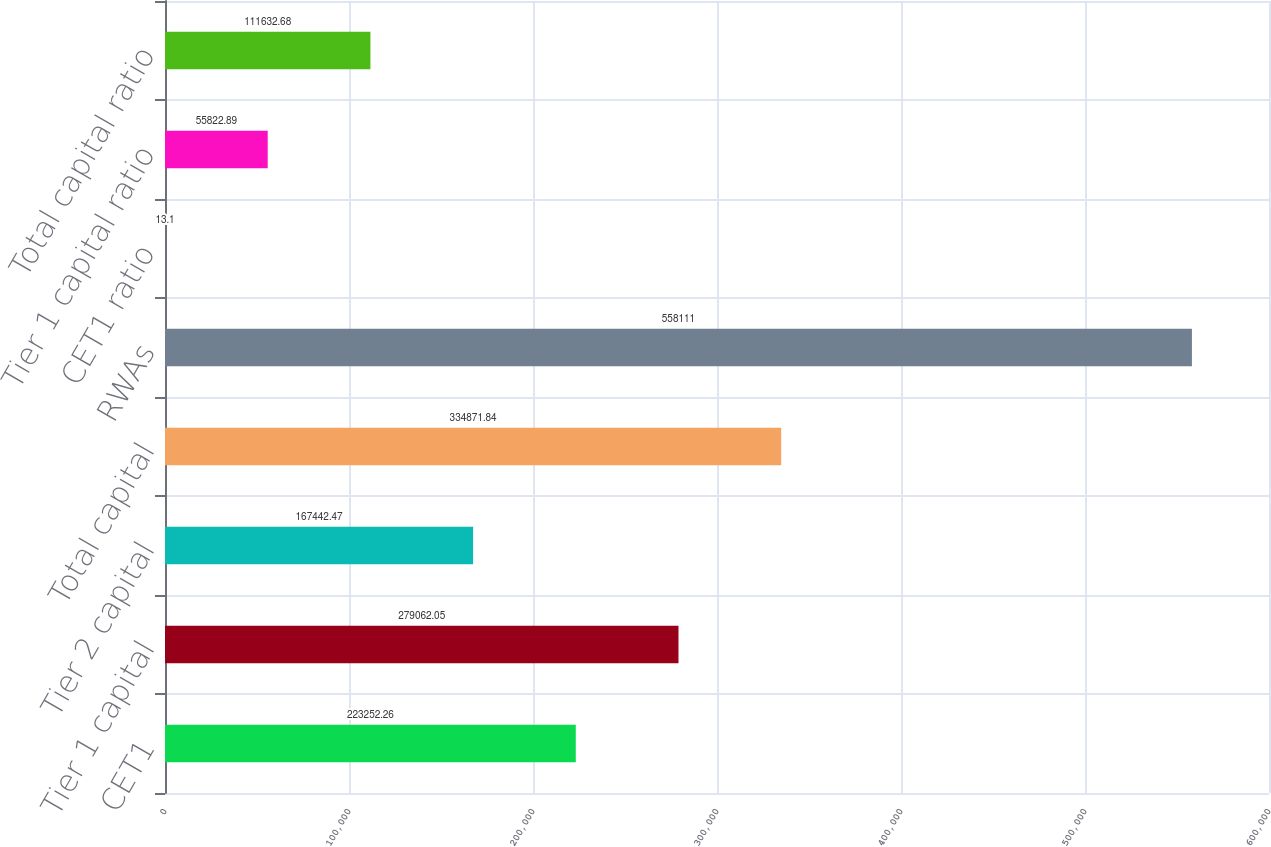Convert chart to OTSL. <chart><loc_0><loc_0><loc_500><loc_500><bar_chart><fcel>CET1<fcel>Tier 1 capital<fcel>Tier 2 capital<fcel>Total capital<fcel>RWAs<fcel>CET1 ratio<fcel>Tier 1 capital ratio<fcel>Total capital ratio<nl><fcel>223252<fcel>279062<fcel>167442<fcel>334872<fcel>558111<fcel>13.1<fcel>55822.9<fcel>111633<nl></chart> 